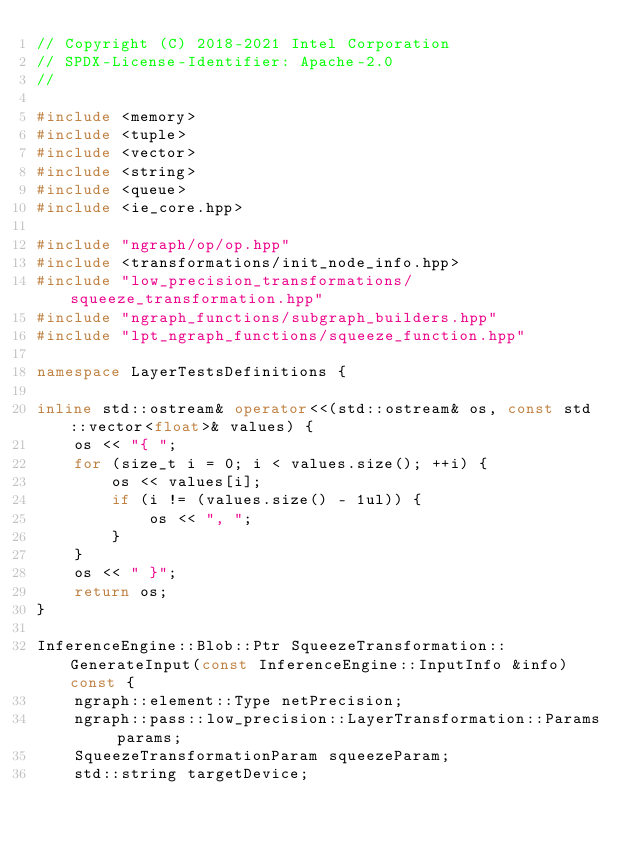Convert code to text. <code><loc_0><loc_0><loc_500><loc_500><_C++_>// Copyright (C) 2018-2021 Intel Corporation
// SPDX-License-Identifier: Apache-2.0
//

#include <memory>
#include <tuple>
#include <vector>
#include <string>
#include <queue>
#include <ie_core.hpp>

#include "ngraph/op/op.hpp"
#include <transformations/init_node_info.hpp>
#include "low_precision_transformations/squeeze_transformation.hpp"
#include "ngraph_functions/subgraph_builders.hpp"
#include "lpt_ngraph_functions/squeeze_function.hpp"

namespace LayerTestsDefinitions {

inline std::ostream& operator<<(std::ostream& os, const std::vector<float>& values) {
    os << "{ ";
    for (size_t i = 0; i < values.size(); ++i) {
        os << values[i];
        if (i != (values.size() - 1ul)) {
            os << ", ";
        }
    }
    os << " }";
    return os;
}

InferenceEngine::Blob::Ptr SqueezeTransformation::GenerateInput(const InferenceEngine::InputInfo &info) const {
    ngraph::element::Type netPrecision;
    ngraph::pass::low_precision::LayerTransformation::Params params;
    SqueezeTransformationParam squeezeParam;
    std::string targetDevice;
</code> 